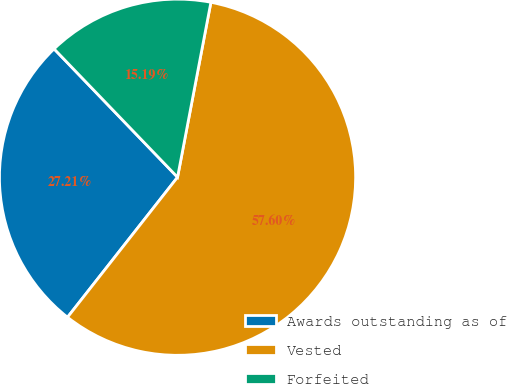Convert chart to OTSL. <chart><loc_0><loc_0><loc_500><loc_500><pie_chart><fcel>Awards outstanding as of<fcel>Vested<fcel>Forfeited<nl><fcel>27.21%<fcel>57.6%<fcel>15.19%<nl></chart> 